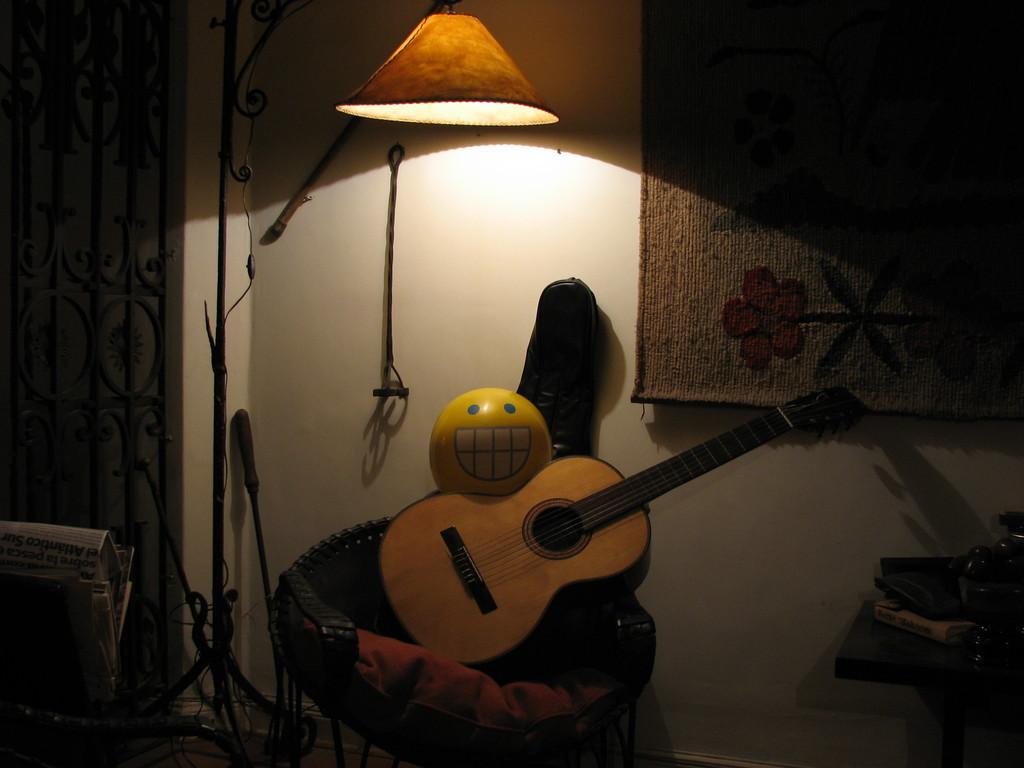Describe this image in one or two sentences. In this image I can see a guitar and some of the objects and there is also a lamp. 